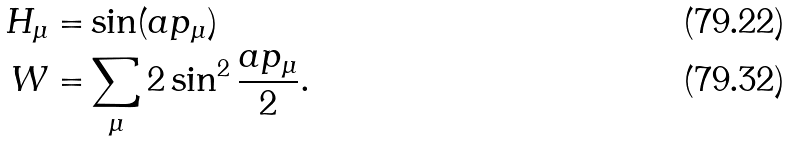Convert formula to latex. <formula><loc_0><loc_0><loc_500><loc_500>H _ { \mu } = & \sin ( a p _ { \mu } ) \\ W = & \sum _ { \mu } 2 \sin ^ { 2 } \frac { a p _ { \mu } } { 2 } .</formula> 